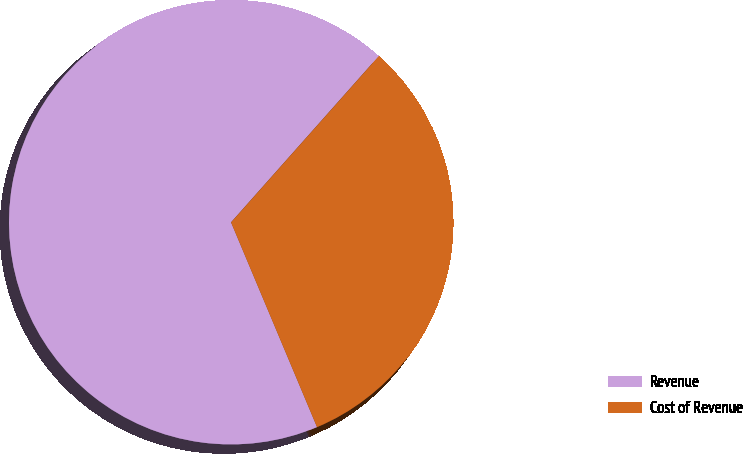Convert chart to OTSL. <chart><loc_0><loc_0><loc_500><loc_500><pie_chart><fcel>Revenue<fcel>Cost of Revenue<nl><fcel>67.89%<fcel>32.11%<nl></chart> 